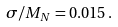<formula> <loc_0><loc_0><loc_500><loc_500>\sigma / M _ { N } = 0 . 0 1 5 \, .</formula> 